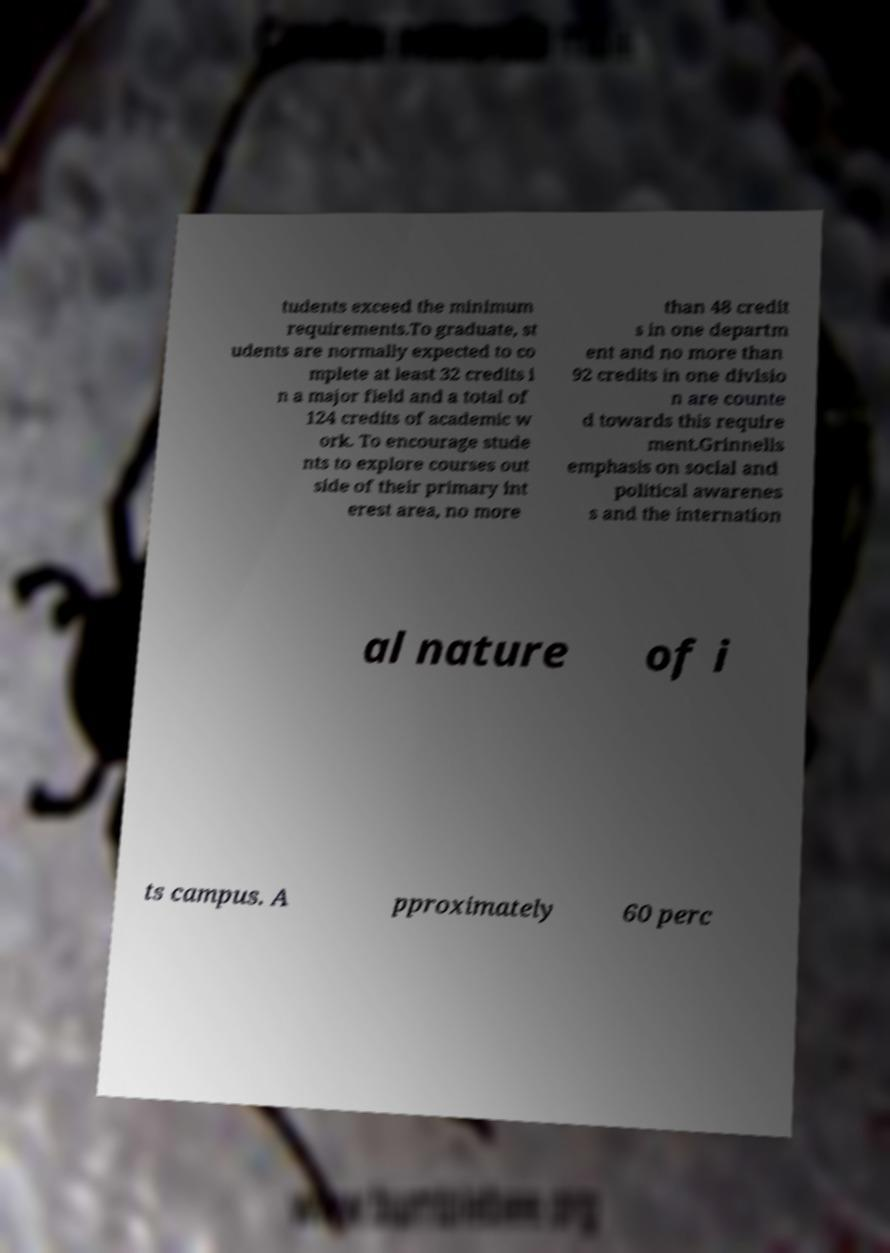Could you assist in decoding the text presented in this image and type it out clearly? tudents exceed the minimum requirements.To graduate, st udents are normally expected to co mplete at least 32 credits i n a major field and a total of 124 credits of academic w ork. To encourage stude nts to explore courses out side of their primary int erest area, no more than 48 credit s in one departm ent and no more than 92 credits in one divisio n are counte d towards this require ment.Grinnells emphasis on social and political awarenes s and the internation al nature of i ts campus. A pproximately 60 perc 